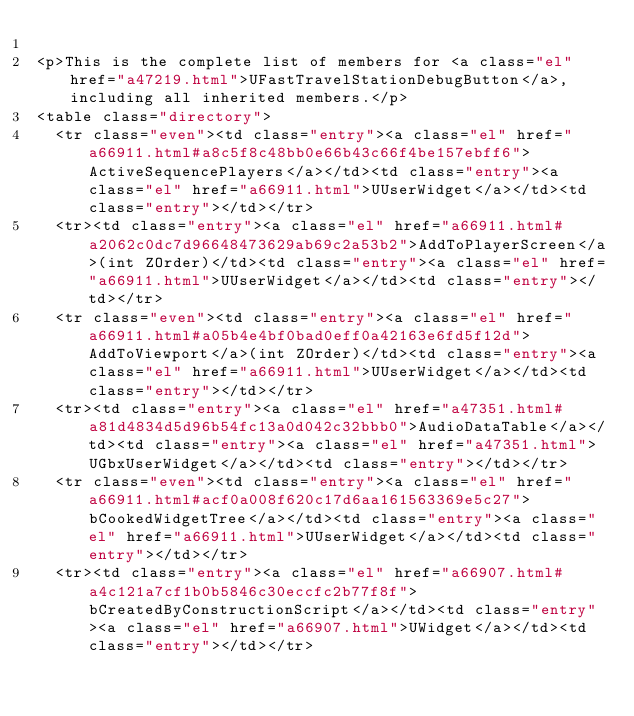Convert code to text. <code><loc_0><loc_0><loc_500><loc_500><_HTML_>
<p>This is the complete list of members for <a class="el" href="a47219.html">UFastTravelStationDebugButton</a>, including all inherited members.</p>
<table class="directory">
  <tr class="even"><td class="entry"><a class="el" href="a66911.html#a8c5f8c48bb0e66b43c66f4be157ebff6">ActiveSequencePlayers</a></td><td class="entry"><a class="el" href="a66911.html">UUserWidget</a></td><td class="entry"></td></tr>
  <tr><td class="entry"><a class="el" href="a66911.html#a2062c0dc7d96648473629ab69c2a53b2">AddToPlayerScreen</a>(int ZOrder)</td><td class="entry"><a class="el" href="a66911.html">UUserWidget</a></td><td class="entry"></td></tr>
  <tr class="even"><td class="entry"><a class="el" href="a66911.html#a05b4e4bf0bad0eff0a42163e6fd5f12d">AddToViewport</a>(int ZOrder)</td><td class="entry"><a class="el" href="a66911.html">UUserWidget</a></td><td class="entry"></td></tr>
  <tr><td class="entry"><a class="el" href="a47351.html#a81d4834d5d96b54fc13a0d042c32bbb0">AudioDataTable</a></td><td class="entry"><a class="el" href="a47351.html">UGbxUserWidget</a></td><td class="entry"></td></tr>
  <tr class="even"><td class="entry"><a class="el" href="a66911.html#acf0a008f620c17d6aa161563369e5c27">bCookedWidgetTree</a></td><td class="entry"><a class="el" href="a66911.html">UUserWidget</a></td><td class="entry"></td></tr>
  <tr><td class="entry"><a class="el" href="a66907.html#a4c121a7cf1b0b5846c30eccfc2b77f8f">bCreatedByConstructionScript</a></td><td class="entry"><a class="el" href="a66907.html">UWidget</a></td><td class="entry"></td></tr></code> 